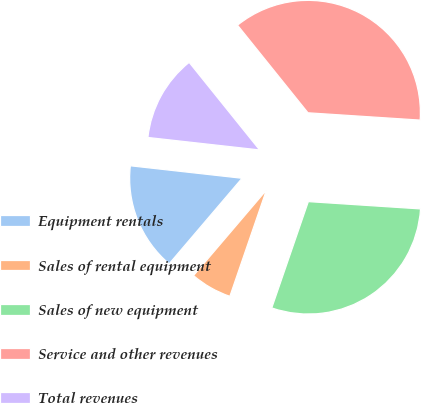Convert chart to OTSL. <chart><loc_0><loc_0><loc_500><loc_500><pie_chart><fcel>Equipment rentals<fcel>Sales of rental equipment<fcel>Sales of new equipment<fcel>Service and other revenues<fcel>Total revenues<nl><fcel>15.54%<fcel>5.96%<fcel>29.24%<fcel>36.82%<fcel>12.45%<nl></chart> 